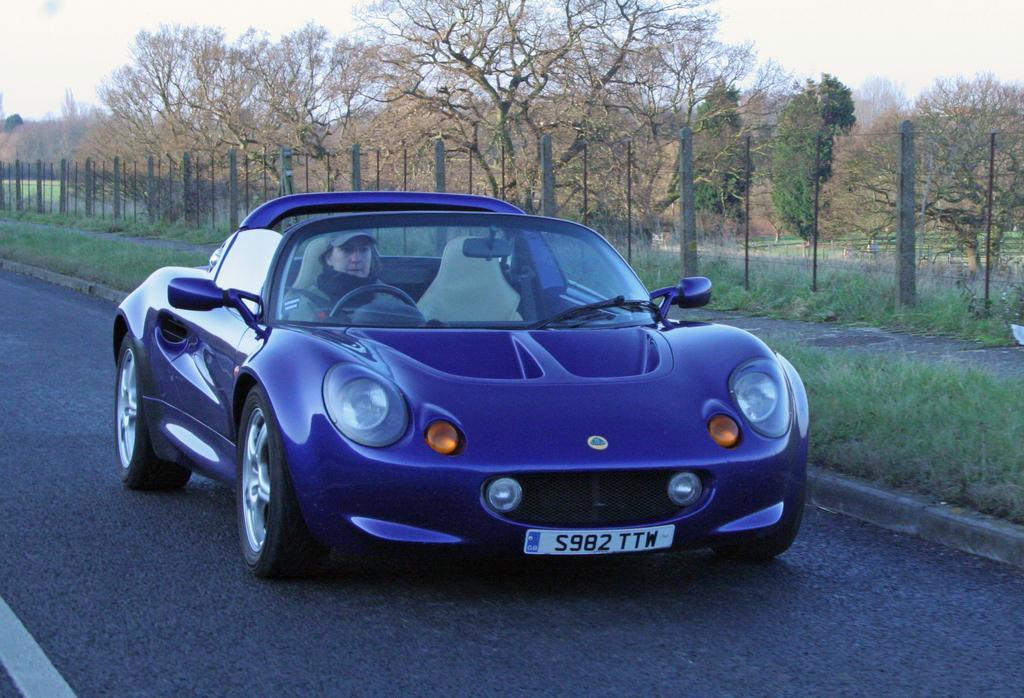Can you describe this image briefly? In the picture I can see a person is sitting in the blue car which is moving on the road. In the background, we can see the fence, trees, grass and the sky. 